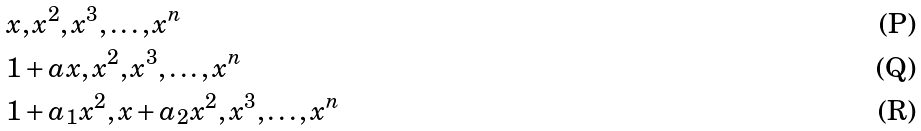<formula> <loc_0><loc_0><loc_500><loc_500>& x , x ^ { 2 } , x ^ { 3 } , \dots , x ^ { n } \\ & 1 + a x , x ^ { 2 } , x ^ { 3 } , \dots , x ^ { n } \\ & 1 + a _ { 1 } x ^ { 2 } , x + a _ { 2 } x ^ { 2 } , x ^ { 3 } , \dots , x ^ { n }</formula> 